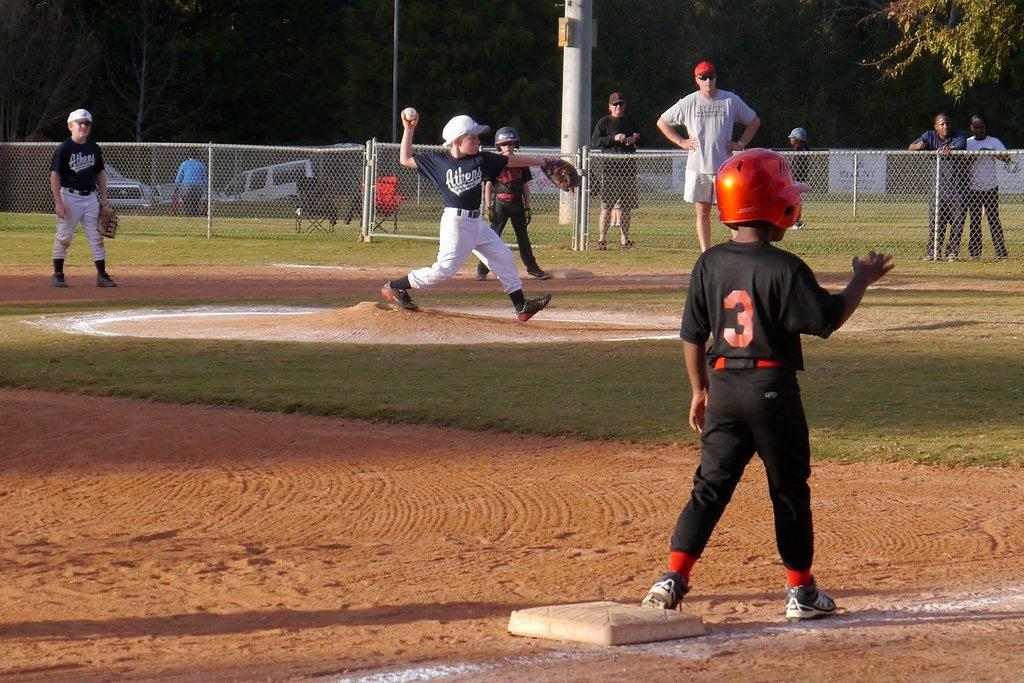<image>
Describe the image concisely. Baseball game between 2 teams with a base runner #3 on third base. 